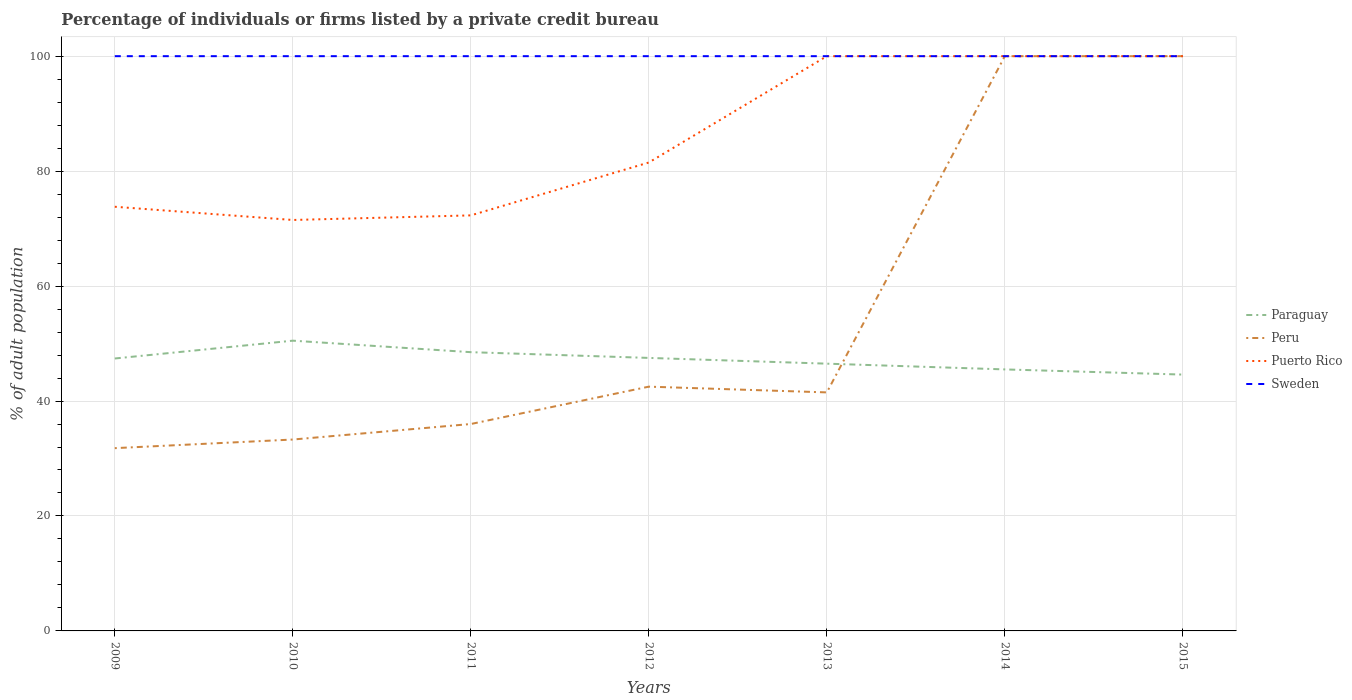How many different coloured lines are there?
Offer a terse response. 4. Does the line corresponding to Peru intersect with the line corresponding to Sweden?
Make the answer very short. Yes. Is the number of lines equal to the number of legend labels?
Your answer should be compact. Yes. Across all years, what is the maximum percentage of population listed by a private credit bureau in Sweden?
Make the answer very short. 100. What is the total percentage of population listed by a private credit bureau in Peru in the graph?
Make the answer very short. -57.5. What is the difference between the highest and the second highest percentage of population listed by a private credit bureau in Peru?
Ensure brevity in your answer.  68.2. How many lines are there?
Provide a succinct answer. 4. What is the difference between two consecutive major ticks on the Y-axis?
Give a very brief answer. 20. Are the values on the major ticks of Y-axis written in scientific E-notation?
Keep it short and to the point. No. Does the graph contain any zero values?
Offer a very short reply. No. Where does the legend appear in the graph?
Your response must be concise. Center right. How many legend labels are there?
Your response must be concise. 4. What is the title of the graph?
Provide a short and direct response. Percentage of individuals or firms listed by a private credit bureau. What is the label or title of the Y-axis?
Your answer should be very brief. % of adult population. What is the % of adult population of Paraguay in 2009?
Your answer should be compact. 47.4. What is the % of adult population of Peru in 2009?
Keep it short and to the point. 31.8. What is the % of adult population in Puerto Rico in 2009?
Provide a short and direct response. 73.8. What is the % of adult population of Sweden in 2009?
Make the answer very short. 100. What is the % of adult population in Paraguay in 2010?
Provide a short and direct response. 50.5. What is the % of adult population in Peru in 2010?
Your response must be concise. 33.3. What is the % of adult population in Puerto Rico in 2010?
Make the answer very short. 71.5. What is the % of adult population in Paraguay in 2011?
Keep it short and to the point. 48.5. What is the % of adult population of Peru in 2011?
Keep it short and to the point. 36. What is the % of adult population in Puerto Rico in 2011?
Keep it short and to the point. 72.3. What is the % of adult population of Paraguay in 2012?
Keep it short and to the point. 47.5. What is the % of adult population of Peru in 2012?
Give a very brief answer. 42.5. What is the % of adult population in Puerto Rico in 2012?
Provide a succinct answer. 81.5. What is the % of adult population in Sweden in 2012?
Give a very brief answer. 100. What is the % of adult population of Paraguay in 2013?
Provide a short and direct response. 46.5. What is the % of adult population in Peru in 2013?
Your response must be concise. 41.5. What is the % of adult population of Puerto Rico in 2013?
Keep it short and to the point. 100. What is the % of adult population of Sweden in 2013?
Provide a short and direct response. 100. What is the % of adult population in Paraguay in 2014?
Your answer should be very brief. 45.5. What is the % of adult population of Puerto Rico in 2014?
Make the answer very short. 100. What is the % of adult population of Sweden in 2014?
Your answer should be very brief. 100. What is the % of adult population in Paraguay in 2015?
Your response must be concise. 44.6. What is the % of adult population of Peru in 2015?
Your answer should be compact. 100. Across all years, what is the maximum % of adult population of Paraguay?
Give a very brief answer. 50.5. Across all years, what is the maximum % of adult population of Puerto Rico?
Give a very brief answer. 100. Across all years, what is the maximum % of adult population of Sweden?
Offer a terse response. 100. Across all years, what is the minimum % of adult population in Paraguay?
Provide a short and direct response. 44.6. Across all years, what is the minimum % of adult population in Peru?
Give a very brief answer. 31.8. Across all years, what is the minimum % of adult population of Puerto Rico?
Keep it short and to the point. 71.5. Across all years, what is the minimum % of adult population in Sweden?
Keep it short and to the point. 100. What is the total % of adult population in Paraguay in the graph?
Make the answer very short. 330.5. What is the total % of adult population in Peru in the graph?
Your answer should be compact. 385.1. What is the total % of adult population in Puerto Rico in the graph?
Your answer should be very brief. 599.1. What is the total % of adult population in Sweden in the graph?
Provide a succinct answer. 700. What is the difference between the % of adult population of Puerto Rico in 2009 and that in 2010?
Keep it short and to the point. 2.3. What is the difference between the % of adult population of Sweden in 2009 and that in 2010?
Keep it short and to the point. 0. What is the difference between the % of adult population in Paraguay in 2009 and that in 2012?
Make the answer very short. -0.1. What is the difference between the % of adult population of Puerto Rico in 2009 and that in 2012?
Offer a very short reply. -7.7. What is the difference between the % of adult population of Paraguay in 2009 and that in 2013?
Ensure brevity in your answer.  0.9. What is the difference between the % of adult population of Peru in 2009 and that in 2013?
Your answer should be very brief. -9.7. What is the difference between the % of adult population in Puerto Rico in 2009 and that in 2013?
Your answer should be compact. -26.2. What is the difference between the % of adult population in Sweden in 2009 and that in 2013?
Provide a succinct answer. 0. What is the difference between the % of adult population in Peru in 2009 and that in 2014?
Your answer should be very brief. -68.2. What is the difference between the % of adult population of Puerto Rico in 2009 and that in 2014?
Keep it short and to the point. -26.2. What is the difference between the % of adult population in Peru in 2009 and that in 2015?
Offer a very short reply. -68.2. What is the difference between the % of adult population in Puerto Rico in 2009 and that in 2015?
Your answer should be very brief. -26.2. What is the difference between the % of adult population in Paraguay in 2010 and that in 2012?
Your answer should be very brief. 3. What is the difference between the % of adult population in Paraguay in 2010 and that in 2013?
Your response must be concise. 4. What is the difference between the % of adult population of Puerto Rico in 2010 and that in 2013?
Your answer should be very brief. -28.5. What is the difference between the % of adult population of Paraguay in 2010 and that in 2014?
Ensure brevity in your answer.  5. What is the difference between the % of adult population of Peru in 2010 and that in 2014?
Provide a short and direct response. -66.7. What is the difference between the % of adult population in Puerto Rico in 2010 and that in 2014?
Your answer should be compact. -28.5. What is the difference between the % of adult population of Sweden in 2010 and that in 2014?
Your answer should be very brief. 0. What is the difference between the % of adult population of Paraguay in 2010 and that in 2015?
Offer a very short reply. 5.9. What is the difference between the % of adult population in Peru in 2010 and that in 2015?
Keep it short and to the point. -66.7. What is the difference between the % of adult population of Puerto Rico in 2010 and that in 2015?
Offer a very short reply. -28.5. What is the difference between the % of adult population of Paraguay in 2011 and that in 2012?
Offer a very short reply. 1. What is the difference between the % of adult population of Peru in 2011 and that in 2012?
Make the answer very short. -6.5. What is the difference between the % of adult population in Paraguay in 2011 and that in 2013?
Your answer should be very brief. 2. What is the difference between the % of adult population of Peru in 2011 and that in 2013?
Offer a terse response. -5.5. What is the difference between the % of adult population in Puerto Rico in 2011 and that in 2013?
Provide a short and direct response. -27.7. What is the difference between the % of adult population in Paraguay in 2011 and that in 2014?
Offer a very short reply. 3. What is the difference between the % of adult population in Peru in 2011 and that in 2014?
Your answer should be compact. -64. What is the difference between the % of adult population in Puerto Rico in 2011 and that in 2014?
Provide a succinct answer. -27.7. What is the difference between the % of adult population of Sweden in 2011 and that in 2014?
Your response must be concise. 0. What is the difference between the % of adult population of Peru in 2011 and that in 2015?
Provide a short and direct response. -64. What is the difference between the % of adult population of Puerto Rico in 2011 and that in 2015?
Your answer should be compact. -27.7. What is the difference between the % of adult population of Puerto Rico in 2012 and that in 2013?
Provide a succinct answer. -18.5. What is the difference between the % of adult population of Peru in 2012 and that in 2014?
Provide a short and direct response. -57.5. What is the difference between the % of adult population of Puerto Rico in 2012 and that in 2014?
Your answer should be compact. -18.5. What is the difference between the % of adult population of Peru in 2012 and that in 2015?
Offer a terse response. -57.5. What is the difference between the % of adult population of Puerto Rico in 2012 and that in 2015?
Offer a very short reply. -18.5. What is the difference between the % of adult population of Sweden in 2012 and that in 2015?
Ensure brevity in your answer.  0. What is the difference between the % of adult population of Peru in 2013 and that in 2014?
Offer a very short reply. -58.5. What is the difference between the % of adult population of Puerto Rico in 2013 and that in 2014?
Ensure brevity in your answer.  0. What is the difference between the % of adult population in Peru in 2013 and that in 2015?
Provide a succinct answer. -58.5. What is the difference between the % of adult population in Puerto Rico in 2013 and that in 2015?
Offer a terse response. 0. What is the difference between the % of adult population in Sweden in 2013 and that in 2015?
Offer a terse response. 0. What is the difference between the % of adult population in Peru in 2014 and that in 2015?
Offer a terse response. 0. What is the difference between the % of adult population in Puerto Rico in 2014 and that in 2015?
Keep it short and to the point. 0. What is the difference between the % of adult population in Paraguay in 2009 and the % of adult population in Puerto Rico in 2010?
Your response must be concise. -24.1. What is the difference between the % of adult population in Paraguay in 2009 and the % of adult population in Sweden in 2010?
Keep it short and to the point. -52.6. What is the difference between the % of adult population of Peru in 2009 and the % of adult population of Puerto Rico in 2010?
Provide a succinct answer. -39.7. What is the difference between the % of adult population of Peru in 2009 and the % of adult population of Sweden in 2010?
Ensure brevity in your answer.  -68.2. What is the difference between the % of adult population of Puerto Rico in 2009 and the % of adult population of Sweden in 2010?
Provide a short and direct response. -26.2. What is the difference between the % of adult population in Paraguay in 2009 and the % of adult population in Puerto Rico in 2011?
Your answer should be compact. -24.9. What is the difference between the % of adult population of Paraguay in 2009 and the % of adult population of Sweden in 2011?
Offer a terse response. -52.6. What is the difference between the % of adult population of Peru in 2009 and the % of adult population of Puerto Rico in 2011?
Keep it short and to the point. -40.5. What is the difference between the % of adult population of Peru in 2009 and the % of adult population of Sweden in 2011?
Your answer should be compact. -68.2. What is the difference between the % of adult population in Puerto Rico in 2009 and the % of adult population in Sweden in 2011?
Offer a terse response. -26.2. What is the difference between the % of adult population in Paraguay in 2009 and the % of adult population in Puerto Rico in 2012?
Ensure brevity in your answer.  -34.1. What is the difference between the % of adult population in Paraguay in 2009 and the % of adult population in Sweden in 2012?
Your answer should be compact. -52.6. What is the difference between the % of adult population in Peru in 2009 and the % of adult population in Puerto Rico in 2012?
Offer a terse response. -49.7. What is the difference between the % of adult population of Peru in 2009 and the % of adult population of Sweden in 2012?
Keep it short and to the point. -68.2. What is the difference between the % of adult population in Puerto Rico in 2009 and the % of adult population in Sweden in 2012?
Your response must be concise. -26.2. What is the difference between the % of adult population of Paraguay in 2009 and the % of adult population of Puerto Rico in 2013?
Make the answer very short. -52.6. What is the difference between the % of adult population of Paraguay in 2009 and the % of adult population of Sweden in 2013?
Keep it short and to the point. -52.6. What is the difference between the % of adult population in Peru in 2009 and the % of adult population in Puerto Rico in 2013?
Keep it short and to the point. -68.2. What is the difference between the % of adult population in Peru in 2009 and the % of adult population in Sweden in 2013?
Your answer should be compact. -68.2. What is the difference between the % of adult population of Puerto Rico in 2009 and the % of adult population of Sweden in 2013?
Keep it short and to the point. -26.2. What is the difference between the % of adult population in Paraguay in 2009 and the % of adult population in Peru in 2014?
Offer a very short reply. -52.6. What is the difference between the % of adult population in Paraguay in 2009 and the % of adult population in Puerto Rico in 2014?
Provide a succinct answer. -52.6. What is the difference between the % of adult population in Paraguay in 2009 and the % of adult population in Sweden in 2014?
Ensure brevity in your answer.  -52.6. What is the difference between the % of adult population in Peru in 2009 and the % of adult population in Puerto Rico in 2014?
Your answer should be compact. -68.2. What is the difference between the % of adult population in Peru in 2009 and the % of adult population in Sweden in 2014?
Make the answer very short. -68.2. What is the difference between the % of adult population in Puerto Rico in 2009 and the % of adult population in Sweden in 2014?
Provide a short and direct response. -26.2. What is the difference between the % of adult population in Paraguay in 2009 and the % of adult population in Peru in 2015?
Provide a short and direct response. -52.6. What is the difference between the % of adult population in Paraguay in 2009 and the % of adult population in Puerto Rico in 2015?
Provide a short and direct response. -52.6. What is the difference between the % of adult population of Paraguay in 2009 and the % of adult population of Sweden in 2015?
Provide a short and direct response. -52.6. What is the difference between the % of adult population of Peru in 2009 and the % of adult population of Puerto Rico in 2015?
Your answer should be very brief. -68.2. What is the difference between the % of adult population of Peru in 2009 and the % of adult population of Sweden in 2015?
Ensure brevity in your answer.  -68.2. What is the difference between the % of adult population of Puerto Rico in 2009 and the % of adult population of Sweden in 2015?
Offer a very short reply. -26.2. What is the difference between the % of adult population in Paraguay in 2010 and the % of adult population in Puerto Rico in 2011?
Your response must be concise. -21.8. What is the difference between the % of adult population of Paraguay in 2010 and the % of adult population of Sweden in 2011?
Your answer should be compact. -49.5. What is the difference between the % of adult population in Peru in 2010 and the % of adult population in Puerto Rico in 2011?
Provide a short and direct response. -39. What is the difference between the % of adult population of Peru in 2010 and the % of adult population of Sweden in 2011?
Give a very brief answer. -66.7. What is the difference between the % of adult population of Puerto Rico in 2010 and the % of adult population of Sweden in 2011?
Your response must be concise. -28.5. What is the difference between the % of adult population in Paraguay in 2010 and the % of adult population in Puerto Rico in 2012?
Provide a succinct answer. -31. What is the difference between the % of adult population in Paraguay in 2010 and the % of adult population in Sweden in 2012?
Offer a terse response. -49.5. What is the difference between the % of adult population in Peru in 2010 and the % of adult population in Puerto Rico in 2012?
Give a very brief answer. -48.2. What is the difference between the % of adult population in Peru in 2010 and the % of adult population in Sweden in 2012?
Give a very brief answer. -66.7. What is the difference between the % of adult population in Puerto Rico in 2010 and the % of adult population in Sweden in 2012?
Provide a short and direct response. -28.5. What is the difference between the % of adult population in Paraguay in 2010 and the % of adult population in Puerto Rico in 2013?
Give a very brief answer. -49.5. What is the difference between the % of adult population of Paraguay in 2010 and the % of adult population of Sweden in 2013?
Offer a terse response. -49.5. What is the difference between the % of adult population of Peru in 2010 and the % of adult population of Puerto Rico in 2013?
Offer a very short reply. -66.7. What is the difference between the % of adult population of Peru in 2010 and the % of adult population of Sweden in 2013?
Provide a short and direct response. -66.7. What is the difference between the % of adult population in Puerto Rico in 2010 and the % of adult population in Sweden in 2013?
Make the answer very short. -28.5. What is the difference between the % of adult population in Paraguay in 2010 and the % of adult population in Peru in 2014?
Your answer should be very brief. -49.5. What is the difference between the % of adult population in Paraguay in 2010 and the % of adult population in Puerto Rico in 2014?
Offer a very short reply. -49.5. What is the difference between the % of adult population of Paraguay in 2010 and the % of adult population of Sweden in 2014?
Ensure brevity in your answer.  -49.5. What is the difference between the % of adult population in Peru in 2010 and the % of adult population in Puerto Rico in 2014?
Make the answer very short. -66.7. What is the difference between the % of adult population in Peru in 2010 and the % of adult population in Sweden in 2014?
Offer a terse response. -66.7. What is the difference between the % of adult population of Puerto Rico in 2010 and the % of adult population of Sweden in 2014?
Your answer should be compact. -28.5. What is the difference between the % of adult population in Paraguay in 2010 and the % of adult population in Peru in 2015?
Provide a succinct answer. -49.5. What is the difference between the % of adult population in Paraguay in 2010 and the % of adult population in Puerto Rico in 2015?
Offer a terse response. -49.5. What is the difference between the % of adult population in Paraguay in 2010 and the % of adult population in Sweden in 2015?
Make the answer very short. -49.5. What is the difference between the % of adult population in Peru in 2010 and the % of adult population in Puerto Rico in 2015?
Your answer should be compact. -66.7. What is the difference between the % of adult population in Peru in 2010 and the % of adult population in Sweden in 2015?
Offer a terse response. -66.7. What is the difference between the % of adult population in Puerto Rico in 2010 and the % of adult population in Sweden in 2015?
Provide a succinct answer. -28.5. What is the difference between the % of adult population in Paraguay in 2011 and the % of adult population in Peru in 2012?
Ensure brevity in your answer.  6. What is the difference between the % of adult population of Paraguay in 2011 and the % of adult population of Puerto Rico in 2012?
Give a very brief answer. -33. What is the difference between the % of adult population in Paraguay in 2011 and the % of adult population in Sweden in 2012?
Make the answer very short. -51.5. What is the difference between the % of adult population of Peru in 2011 and the % of adult population of Puerto Rico in 2012?
Your response must be concise. -45.5. What is the difference between the % of adult population of Peru in 2011 and the % of adult population of Sweden in 2012?
Provide a succinct answer. -64. What is the difference between the % of adult population of Puerto Rico in 2011 and the % of adult population of Sweden in 2012?
Keep it short and to the point. -27.7. What is the difference between the % of adult population in Paraguay in 2011 and the % of adult population in Puerto Rico in 2013?
Give a very brief answer. -51.5. What is the difference between the % of adult population of Paraguay in 2011 and the % of adult population of Sweden in 2013?
Keep it short and to the point. -51.5. What is the difference between the % of adult population in Peru in 2011 and the % of adult population in Puerto Rico in 2013?
Provide a short and direct response. -64. What is the difference between the % of adult population in Peru in 2011 and the % of adult population in Sweden in 2013?
Your response must be concise. -64. What is the difference between the % of adult population in Puerto Rico in 2011 and the % of adult population in Sweden in 2013?
Give a very brief answer. -27.7. What is the difference between the % of adult population of Paraguay in 2011 and the % of adult population of Peru in 2014?
Make the answer very short. -51.5. What is the difference between the % of adult population of Paraguay in 2011 and the % of adult population of Puerto Rico in 2014?
Your response must be concise. -51.5. What is the difference between the % of adult population in Paraguay in 2011 and the % of adult population in Sweden in 2014?
Your answer should be very brief. -51.5. What is the difference between the % of adult population in Peru in 2011 and the % of adult population in Puerto Rico in 2014?
Your answer should be very brief. -64. What is the difference between the % of adult population in Peru in 2011 and the % of adult population in Sweden in 2014?
Provide a short and direct response. -64. What is the difference between the % of adult population in Puerto Rico in 2011 and the % of adult population in Sweden in 2014?
Ensure brevity in your answer.  -27.7. What is the difference between the % of adult population of Paraguay in 2011 and the % of adult population of Peru in 2015?
Your answer should be compact. -51.5. What is the difference between the % of adult population of Paraguay in 2011 and the % of adult population of Puerto Rico in 2015?
Your answer should be compact. -51.5. What is the difference between the % of adult population of Paraguay in 2011 and the % of adult population of Sweden in 2015?
Your answer should be compact. -51.5. What is the difference between the % of adult population in Peru in 2011 and the % of adult population in Puerto Rico in 2015?
Your answer should be compact. -64. What is the difference between the % of adult population in Peru in 2011 and the % of adult population in Sweden in 2015?
Offer a terse response. -64. What is the difference between the % of adult population in Puerto Rico in 2011 and the % of adult population in Sweden in 2015?
Your answer should be compact. -27.7. What is the difference between the % of adult population in Paraguay in 2012 and the % of adult population in Peru in 2013?
Offer a terse response. 6. What is the difference between the % of adult population in Paraguay in 2012 and the % of adult population in Puerto Rico in 2013?
Give a very brief answer. -52.5. What is the difference between the % of adult population in Paraguay in 2012 and the % of adult population in Sweden in 2013?
Ensure brevity in your answer.  -52.5. What is the difference between the % of adult population of Peru in 2012 and the % of adult population of Puerto Rico in 2013?
Offer a terse response. -57.5. What is the difference between the % of adult population of Peru in 2012 and the % of adult population of Sweden in 2013?
Provide a succinct answer. -57.5. What is the difference between the % of adult population in Puerto Rico in 2012 and the % of adult population in Sweden in 2013?
Provide a succinct answer. -18.5. What is the difference between the % of adult population in Paraguay in 2012 and the % of adult population in Peru in 2014?
Keep it short and to the point. -52.5. What is the difference between the % of adult population in Paraguay in 2012 and the % of adult population in Puerto Rico in 2014?
Provide a succinct answer. -52.5. What is the difference between the % of adult population in Paraguay in 2012 and the % of adult population in Sweden in 2014?
Offer a very short reply. -52.5. What is the difference between the % of adult population of Peru in 2012 and the % of adult population of Puerto Rico in 2014?
Your answer should be compact. -57.5. What is the difference between the % of adult population of Peru in 2012 and the % of adult population of Sweden in 2014?
Give a very brief answer. -57.5. What is the difference between the % of adult population in Puerto Rico in 2012 and the % of adult population in Sweden in 2014?
Offer a terse response. -18.5. What is the difference between the % of adult population of Paraguay in 2012 and the % of adult population of Peru in 2015?
Provide a short and direct response. -52.5. What is the difference between the % of adult population of Paraguay in 2012 and the % of adult population of Puerto Rico in 2015?
Make the answer very short. -52.5. What is the difference between the % of adult population of Paraguay in 2012 and the % of adult population of Sweden in 2015?
Your response must be concise. -52.5. What is the difference between the % of adult population in Peru in 2012 and the % of adult population in Puerto Rico in 2015?
Your answer should be compact. -57.5. What is the difference between the % of adult population in Peru in 2012 and the % of adult population in Sweden in 2015?
Keep it short and to the point. -57.5. What is the difference between the % of adult population of Puerto Rico in 2012 and the % of adult population of Sweden in 2015?
Your answer should be compact. -18.5. What is the difference between the % of adult population of Paraguay in 2013 and the % of adult population of Peru in 2014?
Your response must be concise. -53.5. What is the difference between the % of adult population in Paraguay in 2013 and the % of adult population in Puerto Rico in 2014?
Your answer should be very brief. -53.5. What is the difference between the % of adult population in Paraguay in 2013 and the % of adult population in Sweden in 2014?
Your response must be concise. -53.5. What is the difference between the % of adult population of Peru in 2013 and the % of adult population of Puerto Rico in 2014?
Offer a terse response. -58.5. What is the difference between the % of adult population of Peru in 2013 and the % of adult population of Sweden in 2014?
Provide a short and direct response. -58.5. What is the difference between the % of adult population of Paraguay in 2013 and the % of adult population of Peru in 2015?
Make the answer very short. -53.5. What is the difference between the % of adult population in Paraguay in 2013 and the % of adult population in Puerto Rico in 2015?
Offer a terse response. -53.5. What is the difference between the % of adult population of Paraguay in 2013 and the % of adult population of Sweden in 2015?
Keep it short and to the point. -53.5. What is the difference between the % of adult population in Peru in 2013 and the % of adult population in Puerto Rico in 2015?
Offer a terse response. -58.5. What is the difference between the % of adult population of Peru in 2013 and the % of adult population of Sweden in 2015?
Offer a terse response. -58.5. What is the difference between the % of adult population in Puerto Rico in 2013 and the % of adult population in Sweden in 2015?
Make the answer very short. 0. What is the difference between the % of adult population of Paraguay in 2014 and the % of adult population of Peru in 2015?
Ensure brevity in your answer.  -54.5. What is the difference between the % of adult population of Paraguay in 2014 and the % of adult population of Puerto Rico in 2015?
Give a very brief answer. -54.5. What is the difference between the % of adult population in Paraguay in 2014 and the % of adult population in Sweden in 2015?
Keep it short and to the point. -54.5. What is the difference between the % of adult population in Peru in 2014 and the % of adult population in Puerto Rico in 2015?
Offer a very short reply. 0. What is the difference between the % of adult population of Puerto Rico in 2014 and the % of adult population of Sweden in 2015?
Provide a succinct answer. 0. What is the average % of adult population of Paraguay per year?
Provide a succinct answer. 47.21. What is the average % of adult population in Peru per year?
Make the answer very short. 55.01. What is the average % of adult population in Puerto Rico per year?
Provide a short and direct response. 85.59. What is the average % of adult population in Sweden per year?
Ensure brevity in your answer.  100. In the year 2009, what is the difference between the % of adult population in Paraguay and % of adult population in Puerto Rico?
Offer a very short reply. -26.4. In the year 2009, what is the difference between the % of adult population of Paraguay and % of adult population of Sweden?
Give a very brief answer. -52.6. In the year 2009, what is the difference between the % of adult population in Peru and % of adult population in Puerto Rico?
Your response must be concise. -42. In the year 2009, what is the difference between the % of adult population of Peru and % of adult population of Sweden?
Make the answer very short. -68.2. In the year 2009, what is the difference between the % of adult population of Puerto Rico and % of adult population of Sweden?
Your response must be concise. -26.2. In the year 2010, what is the difference between the % of adult population of Paraguay and % of adult population of Peru?
Offer a terse response. 17.2. In the year 2010, what is the difference between the % of adult population of Paraguay and % of adult population of Puerto Rico?
Provide a succinct answer. -21. In the year 2010, what is the difference between the % of adult population in Paraguay and % of adult population in Sweden?
Keep it short and to the point. -49.5. In the year 2010, what is the difference between the % of adult population in Peru and % of adult population in Puerto Rico?
Make the answer very short. -38.2. In the year 2010, what is the difference between the % of adult population in Peru and % of adult population in Sweden?
Your answer should be compact. -66.7. In the year 2010, what is the difference between the % of adult population in Puerto Rico and % of adult population in Sweden?
Your response must be concise. -28.5. In the year 2011, what is the difference between the % of adult population of Paraguay and % of adult population of Puerto Rico?
Ensure brevity in your answer.  -23.8. In the year 2011, what is the difference between the % of adult population in Paraguay and % of adult population in Sweden?
Your response must be concise. -51.5. In the year 2011, what is the difference between the % of adult population of Peru and % of adult population of Puerto Rico?
Ensure brevity in your answer.  -36.3. In the year 2011, what is the difference between the % of adult population in Peru and % of adult population in Sweden?
Ensure brevity in your answer.  -64. In the year 2011, what is the difference between the % of adult population of Puerto Rico and % of adult population of Sweden?
Make the answer very short. -27.7. In the year 2012, what is the difference between the % of adult population of Paraguay and % of adult population of Peru?
Ensure brevity in your answer.  5. In the year 2012, what is the difference between the % of adult population of Paraguay and % of adult population of Puerto Rico?
Give a very brief answer. -34. In the year 2012, what is the difference between the % of adult population of Paraguay and % of adult population of Sweden?
Give a very brief answer. -52.5. In the year 2012, what is the difference between the % of adult population of Peru and % of adult population of Puerto Rico?
Your response must be concise. -39. In the year 2012, what is the difference between the % of adult population in Peru and % of adult population in Sweden?
Ensure brevity in your answer.  -57.5. In the year 2012, what is the difference between the % of adult population of Puerto Rico and % of adult population of Sweden?
Your answer should be compact. -18.5. In the year 2013, what is the difference between the % of adult population of Paraguay and % of adult population of Puerto Rico?
Your answer should be very brief. -53.5. In the year 2013, what is the difference between the % of adult population of Paraguay and % of adult population of Sweden?
Provide a succinct answer. -53.5. In the year 2013, what is the difference between the % of adult population in Peru and % of adult population in Puerto Rico?
Offer a very short reply. -58.5. In the year 2013, what is the difference between the % of adult population in Peru and % of adult population in Sweden?
Make the answer very short. -58.5. In the year 2014, what is the difference between the % of adult population of Paraguay and % of adult population of Peru?
Your response must be concise. -54.5. In the year 2014, what is the difference between the % of adult population in Paraguay and % of adult population in Puerto Rico?
Make the answer very short. -54.5. In the year 2014, what is the difference between the % of adult population of Paraguay and % of adult population of Sweden?
Keep it short and to the point. -54.5. In the year 2014, what is the difference between the % of adult population in Peru and % of adult population in Puerto Rico?
Make the answer very short. 0. In the year 2015, what is the difference between the % of adult population of Paraguay and % of adult population of Peru?
Make the answer very short. -55.4. In the year 2015, what is the difference between the % of adult population in Paraguay and % of adult population in Puerto Rico?
Ensure brevity in your answer.  -55.4. In the year 2015, what is the difference between the % of adult population of Paraguay and % of adult population of Sweden?
Your answer should be very brief. -55.4. In the year 2015, what is the difference between the % of adult population in Puerto Rico and % of adult population in Sweden?
Make the answer very short. 0. What is the ratio of the % of adult population of Paraguay in 2009 to that in 2010?
Your answer should be very brief. 0.94. What is the ratio of the % of adult population of Peru in 2009 to that in 2010?
Provide a succinct answer. 0.95. What is the ratio of the % of adult population of Puerto Rico in 2009 to that in 2010?
Offer a very short reply. 1.03. What is the ratio of the % of adult population of Paraguay in 2009 to that in 2011?
Your answer should be very brief. 0.98. What is the ratio of the % of adult population in Peru in 2009 to that in 2011?
Offer a terse response. 0.88. What is the ratio of the % of adult population in Puerto Rico in 2009 to that in 2011?
Make the answer very short. 1.02. What is the ratio of the % of adult population in Peru in 2009 to that in 2012?
Your answer should be compact. 0.75. What is the ratio of the % of adult population in Puerto Rico in 2009 to that in 2012?
Your response must be concise. 0.91. What is the ratio of the % of adult population in Paraguay in 2009 to that in 2013?
Provide a succinct answer. 1.02. What is the ratio of the % of adult population in Peru in 2009 to that in 2013?
Ensure brevity in your answer.  0.77. What is the ratio of the % of adult population in Puerto Rico in 2009 to that in 2013?
Provide a succinct answer. 0.74. What is the ratio of the % of adult population in Sweden in 2009 to that in 2013?
Make the answer very short. 1. What is the ratio of the % of adult population of Paraguay in 2009 to that in 2014?
Provide a succinct answer. 1.04. What is the ratio of the % of adult population in Peru in 2009 to that in 2014?
Keep it short and to the point. 0.32. What is the ratio of the % of adult population of Puerto Rico in 2009 to that in 2014?
Your answer should be compact. 0.74. What is the ratio of the % of adult population in Sweden in 2009 to that in 2014?
Ensure brevity in your answer.  1. What is the ratio of the % of adult population of Paraguay in 2009 to that in 2015?
Make the answer very short. 1.06. What is the ratio of the % of adult population of Peru in 2009 to that in 2015?
Your answer should be compact. 0.32. What is the ratio of the % of adult population of Puerto Rico in 2009 to that in 2015?
Your response must be concise. 0.74. What is the ratio of the % of adult population in Sweden in 2009 to that in 2015?
Your response must be concise. 1. What is the ratio of the % of adult population of Paraguay in 2010 to that in 2011?
Provide a short and direct response. 1.04. What is the ratio of the % of adult population of Peru in 2010 to that in 2011?
Your response must be concise. 0.93. What is the ratio of the % of adult population in Puerto Rico in 2010 to that in 2011?
Your answer should be very brief. 0.99. What is the ratio of the % of adult population in Paraguay in 2010 to that in 2012?
Your answer should be compact. 1.06. What is the ratio of the % of adult population of Peru in 2010 to that in 2012?
Offer a very short reply. 0.78. What is the ratio of the % of adult population in Puerto Rico in 2010 to that in 2012?
Keep it short and to the point. 0.88. What is the ratio of the % of adult population in Paraguay in 2010 to that in 2013?
Offer a terse response. 1.09. What is the ratio of the % of adult population in Peru in 2010 to that in 2013?
Give a very brief answer. 0.8. What is the ratio of the % of adult population of Puerto Rico in 2010 to that in 2013?
Your answer should be very brief. 0.71. What is the ratio of the % of adult population of Sweden in 2010 to that in 2013?
Your answer should be very brief. 1. What is the ratio of the % of adult population in Paraguay in 2010 to that in 2014?
Give a very brief answer. 1.11. What is the ratio of the % of adult population of Peru in 2010 to that in 2014?
Provide a succinct answer. 0.33. What is the ratio of the % of adult population in Puerto Rico in 2010 to that in 2014?
Your response must be concise. 0.71. What is the ratio of the % of adult population in Paraguay in 2010 to that in 2015?
Ensure brevity in your answer.  1.13. What is the ratio of the % of adult population of Peru in 2010 to that in 2015?
Give a very brief answer. 0.33. What is the ratio of the % of adult population in Puerto Rico in 2010 to that in 2015?
Make the answer very short. 0.71. What is the ratio of the % of adult population of Paraguay in 2011 to that in 2012?
Keep it short and to the point. 1.02. What is the ratio of the % of adult population of Peru in 2011 to that in 2012?
Ensure brevity in your answer.  0.85. What is the ratio of the % of adult population of Puerto Rico in 2011 to that in 2012?
Your response must be concise. 0.89. What is the ratio of the % of adult population in Sweden in 2011 to that in 2012?
Make the answer very short. 1. What is the ratio of the % of adult population of Paraguay in 2011 to that in 2013?
Give a very brief answer. 1.04. What is the ratio of the % of adult population of Peru in 2011 to that in 2013?
Offer a terse response. 0.87. What is the ratio of the % of adult population in Puerto Rico in 2011 to that in 2013?
Ensure brevity in your answer.  0.72. What is the ratio of the % of adult population of Paraguay in 2011 to that in 2014?
Your response must be concise. 1.07. What is the ratio of the % of adult population in Peru in 2011 to that in 2014?
Your answer should be compact. 0.36. What is the ratio of the % of adult population of Puerto Rico in 2011 to that in 2014?
Provide a short and direct response. 0.72. What is the ratio of the % of adult population in Sweden in 2011 to that in 2014?
Offer a terse response. 1. What is the ratio of the % of adult population in Paraguay in 2011 to that in 2015?
Ensure brevity in your answer.  1.09. What is the ratio of the % of adult population in Peru in 2011 to that in 2015?
Provide a short and direct response. 0.36. What is the ratio of the % of adult population in Puerto Rico in 2011 to that in 2015?
Offer a terse response. 0.72. What is the ratio of the % of adult population of Paraguay in 2012 to that in 2013?
Make the answer very short. 1.02. What is the ratio of the % of adult population of Peru in 2012 to that in 2013?
Provide a succinct answer. 1.02. What is the ratio of the % of adult population in Puerto Rico in 2012 to that in 2013?
Ensure brevity in your answer.  0.81. What is the ratio of the % of adult population in Sweden in 2012 to that in 2013?
Ensure brevity in your answer.  1. What is the ratio of the % of adult population in Paraguay in 2012 to that in 2014?
Give a very brief answer. 1.04. What is the ratio of the % of adult population of Peru in 2012 to that in 2014?
Ensure brevity in your answer.  0.42. What is the ratio of the % of adult population of Puerto Rico in 2012 to that in 2014?
Your response must be concise. 0.81. What is the ratio of the % of adult population of Paraguay in 2012 to that in 2015?
Give a very brief answer. 1.06. What is the ratio of the % of adult population of Peru in 2012 to that in 2015?
Ensure brevity in your answer.  0.42. What is the ratio of the % of adult population in Puerto Rico in 2012 to that in 2015?
Your response must be concise. 0.81. What is the ratio of the % of adult population of Sweden in 2012 to that in 2015?
Offer a terse response. 1. What is the ratio of the % of adult population of Peru in 2013 to that in 2014?
Make the answer very short. 0.41. What is the ratio of the % of adult population in Puerto Rico in 2013 to that in 2014?
Keep it short and to the point. 1. What is the ratio of the % of adult population in Sweden in 2013 to that in 2014?
Offer a terse response. 1. What is the ratio of the % of adult population in Paraguay in 2013 to that in 2015?
Your answer should be very brief. 1.04. What is the ratio of the % of adult population of Peru in 2013 to that in 2015?
Make the answer very short. 0.41. What is the ratio of the % of adult population of Puerto Rico in 2013 to that in 2015?
Offer a very short reply. 1. What is the ratio of the % of adult population of Paraguay in 2014 to that in 2015?
Your answer should be compact. 1.02. What is the ratio of the % of adult population of Peru in 2014 to that in 2015?
Provide a short and direct response. 1. What is the ratio of the % of adult population of Puerto Rico in 2014 to that in 2015?
Provide a succinct answer. 1. What is the difference between the highest and the second highest % of adult population of Paraguay?
Provide a succinct answer. 2. What is the difference between the highest and the lowest % of adult population in Peru?
Your answer should be compact. 68.2. 